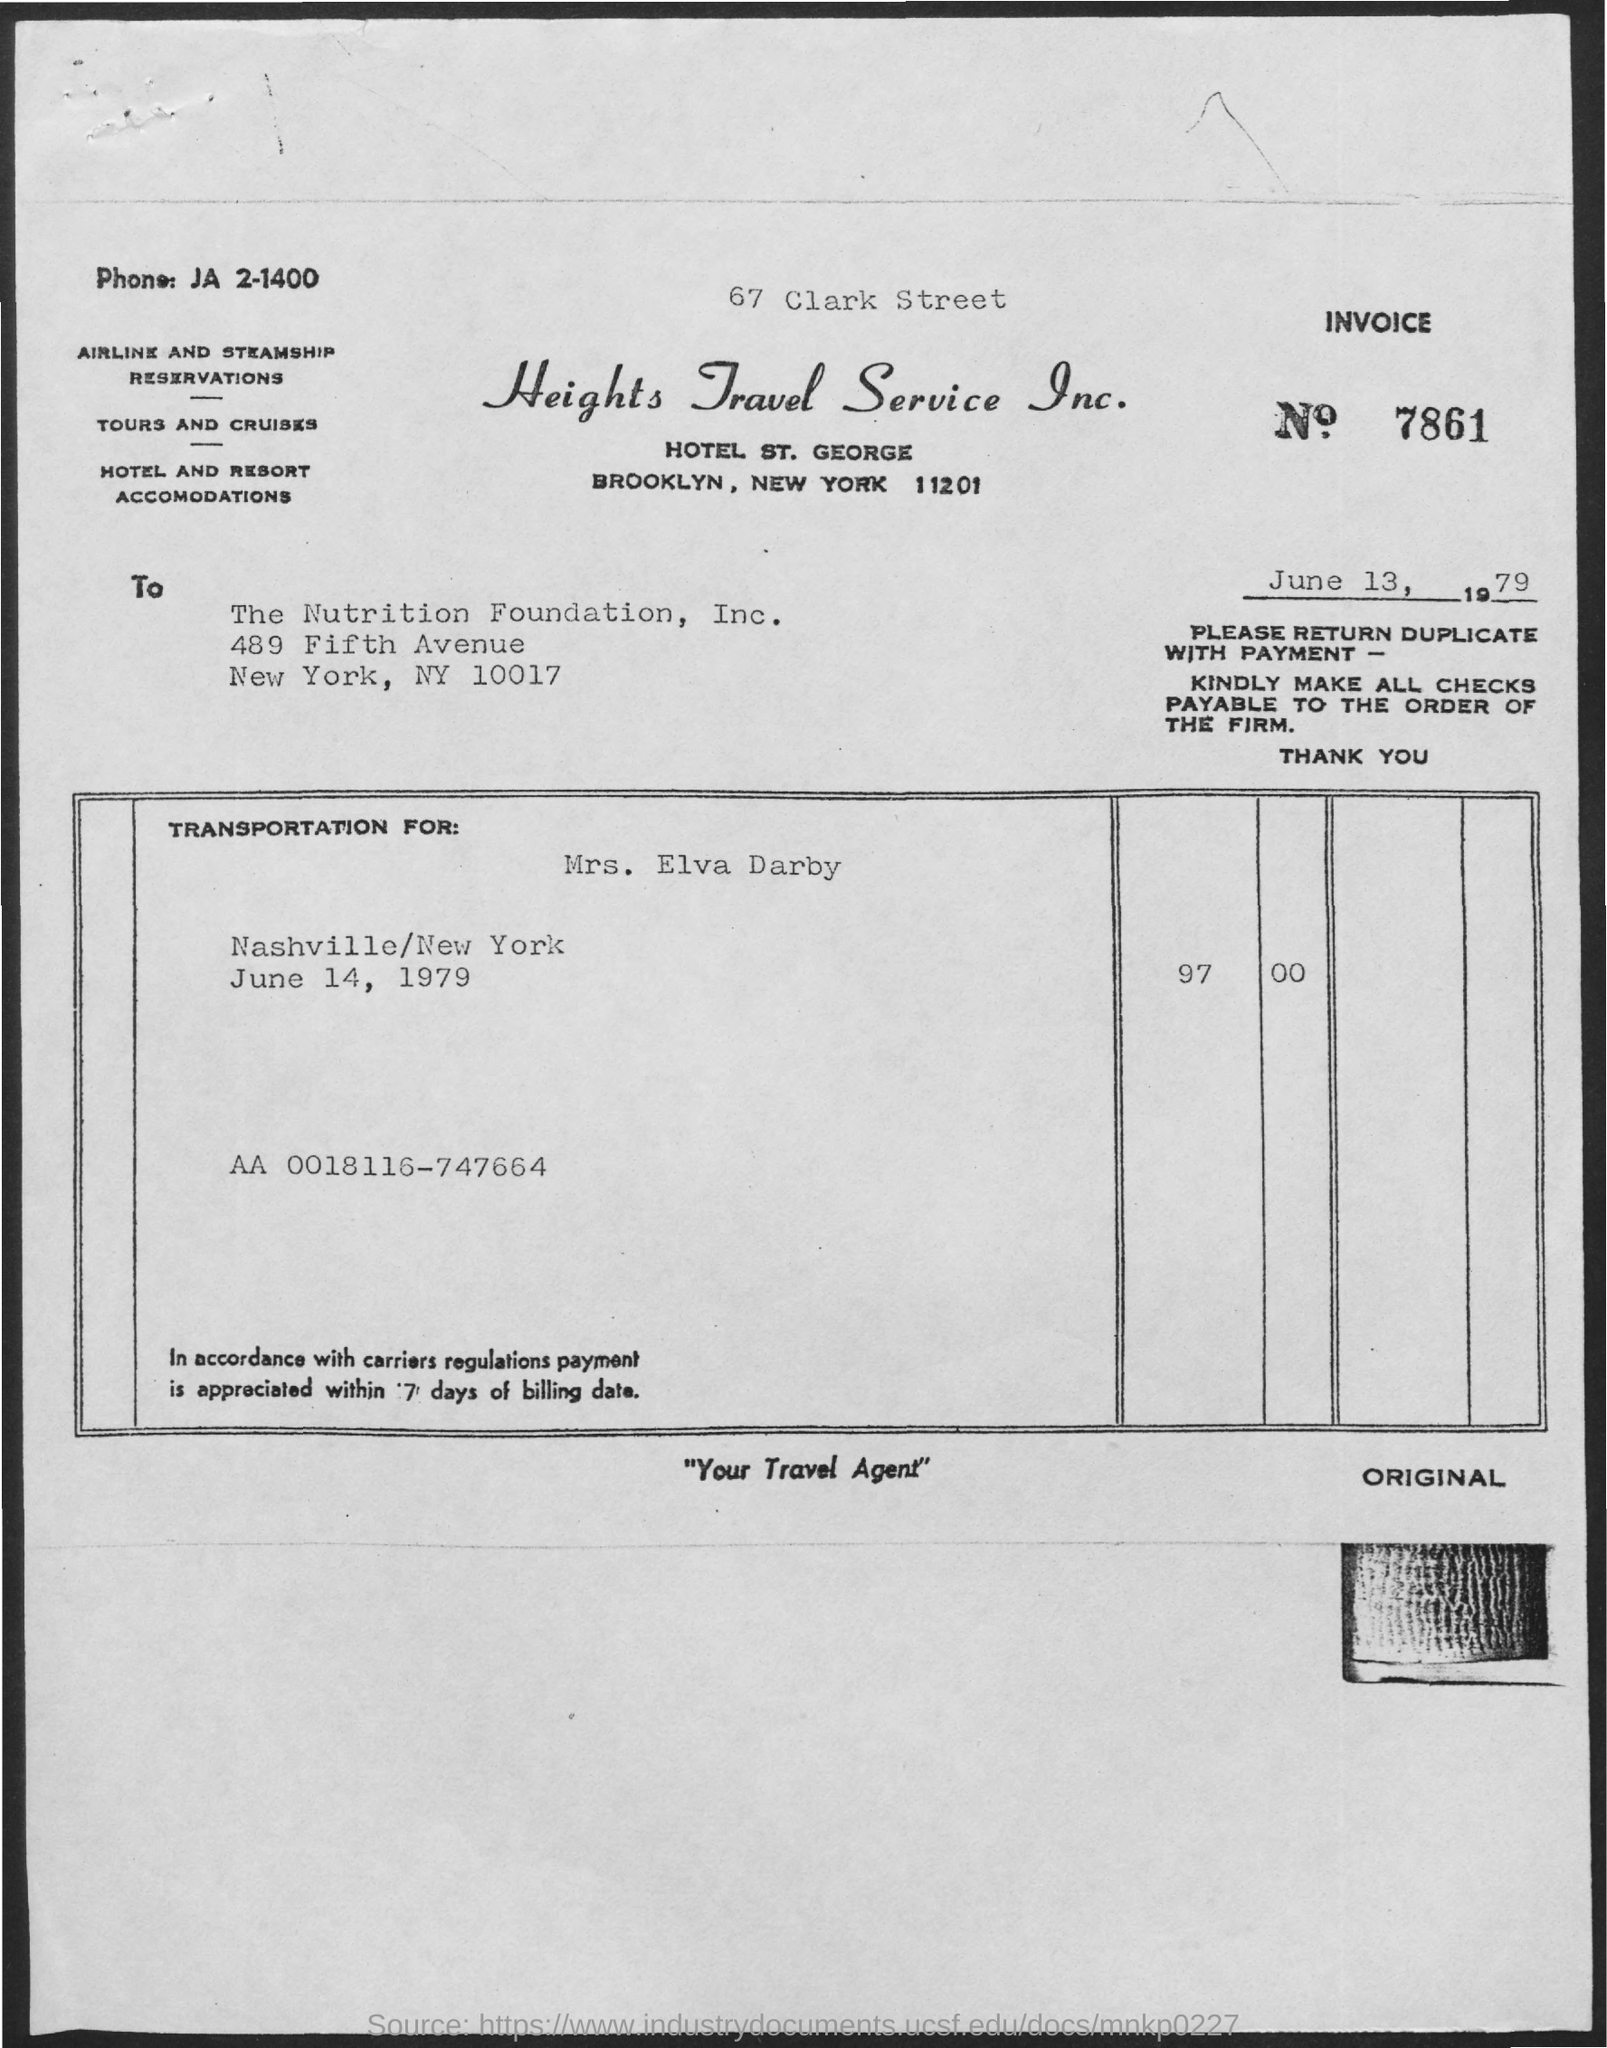What is the Invoice No.?
Provide a succinct answer. 7861. What is the date on the document?
Provide a short and direct response. June 13, 1979. Who is the Transpotation for?
Provide a succinct answer. Mrs. Elva Darby. What is the Total amount?
Your response must be concise. 97.00. 